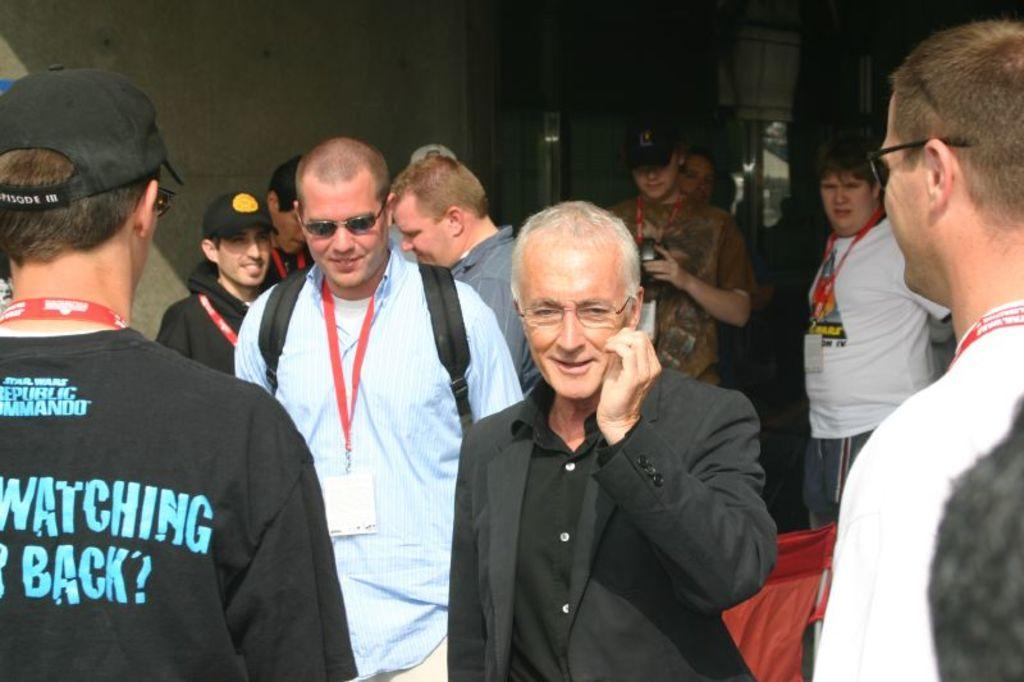What are the people in the image doing? The people in the image are walking. Where are the people walking? The people are walking on a road. What can be seen in the background of the image? The background of the image is dark, and there is a wall visible. What type of apple is being discussed by the committee in the image? There is no committee or apple present in the image; it features people walking on a road with a dark background and a visible wall. 